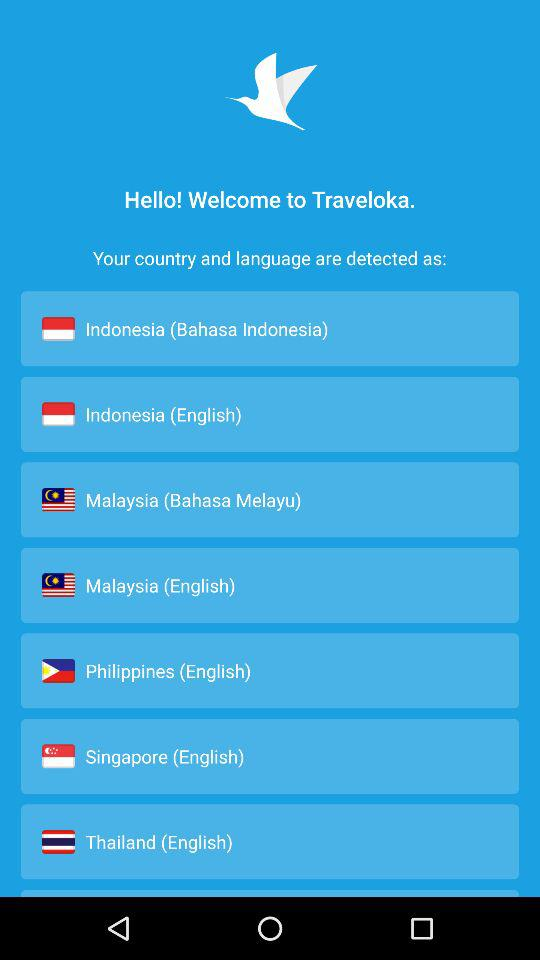In what country is Bahasa Melayu spoken? Bahasa Melayu is spoken in Malaysia. 